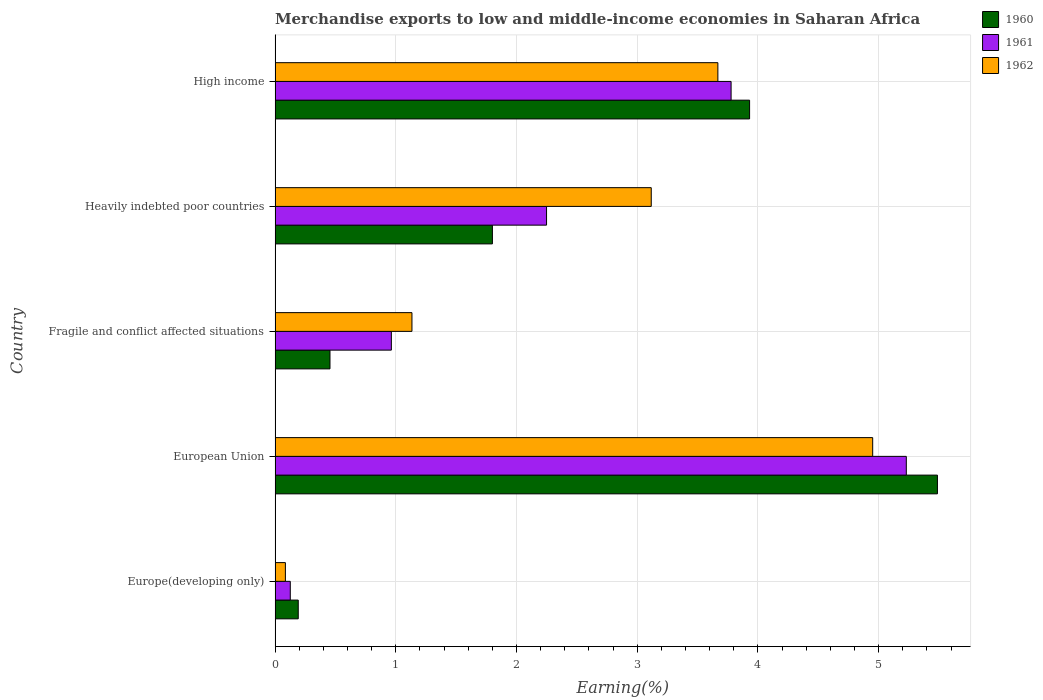How many different coloured bars are there?
Keep it short and to the point. 3. Are the number of bars per tick equal to the number of legend labels?
Your response must be concise. Yes. Are the number of bars on each tick of the Y-axis equal?
Provide a short and direct response. Yes. How many bars are there on the 1st tick from the top?
Offer a terse response. 3. What is the label of the 5th group of bars from the top?
Make the answer very short. Europe(developing only). What is the percentage of amount earned from merchandise exports in 1962 in High income?
Make the answer very short. 3.67. Across all countries, what is the maximum percentage of amount earned from merchandise exports in 1960?
Ensure brevity in your answer.  5.49. Across all countries, what is the minimum percentage of amount earned from merchandise exports in 1962?
Keep it short and to the point. 0.09. In which country was the percentage of amount earned from merchandise exports in 1961 minimum?
Offer a terse response. Europe(developing only). What is the total percentage of amount earned from merchandise exports in 1960 in the graph?
Your answer should be compact. 11.86. What is the difference between the percentage of amount earned from merchandise exports in 1962 in European Union and that in High income?
Offer a terse response. 1.28. What is the difference between the percentage of amount earned from merchandise exports in 1962 in Heavily indebted poor countries and the percentage of amount earned from merchandise exports in 1960 in Fragile and conflict affected situations?
Provide a short and direct response. 2.66. What is the average percentage of amount earned from merchandise exports in 1961 per country?
Ensure brevity in your answer.  2.47. What is the difference between the percentage of amount earned from merchandise exports in 1962 and percentage of amount earned from merchandise exports in 1960 in Europe(developing only)?
Provide a succinct answer. -0.11. What is the ratio of the percentage of amount earned from merchandise exports in 1961 in Europe(developing only) to that in High income?
Your answer should be very brief. 0.03. Is the difference between the percentage of amount earned from merchandise exports in 1962 in Heavily indebted poor countries and High income greater than the difference between the percentage of amount earned from merchandise exports in 1960 in Heavily indebted poor countries and High income?
Keep it short and to the point. Yes. What is the difference between the highest and the second highest percentage of amount earned from merchandise exports in 1960?
Keep it short and to the point. 1.56. What is the difference between the highest and the lowest percentage of amount earned from merchandise exports in 1962?
Offer a very short reply. 4.87. In how many countries, is the percentage of amount earned from merchandise exports in 1961 greater than the average percentage of amount earned from merchandise exports in 1961 taken over all countries?
Provide a short and direct response. 2. What does the 1st bar from the top in Heavily indebted poor countries represents?
Your answer should be very brief. 1962. What does the 2nd bar from the bottom in Fragile and conflict affected situations represents?
Your answer should be compact. 1961. How many bars are there?
Your response must be concise. 15. What is the difference between two consecutive major ticks on the X-axis?
Your answer should be compact. 1. Does the graph contain grids?
Provide a short and direct response. Yes. How many legend labels are there?
Keep it short and to the point. 3. How are the legend labels stacked?
Keep it short and to the point. Vertical. What is the title of the graph?
Give a very brief answer. Merchandise exports to low and middle-income economies in Saharan Africa. Does "1971" appear as one of the legend labels in the graph?
Offer a terse response. No. What is the label or title of the X-axis?
Provide a succinct answer. Earning(%). What is the Earning(%) in 1960 in Europe(developing only)?
Your answer should be very brief. 0.19. What is the Earning(%) in 1961 in Europe(developing only)?
Your answer should be compact. 0.13. What is the Earning(%) in 1962 in Europe(developing only)?
Your answer should be compact. 0.09. What is the Earning(%) in 1960 in European Union?
Your answer should be compact. 5.49. What is the Earning(%) of 1961 in European Union?
Give a very brief answer. 5.23. What is the Earning(%) of 1962 in European Union?
Keep it short and to the point. 4.95. What is the Earning(%) of 1960 in Fragile and conflict affected situations?
Offer a terse response. 0.45. What is the Earning(%) of 1961 in Fragile and conflict affected situations?
Your answer should be very brief. 0.96. What is the Earning(%) in 1962 in Fragile and conflict affected situations?
Your answer should be very brief. 1.13. What is the Earning(%) in 1960 in Heavily indebted poor countries?
Ensure brevity in your answer.  1.8. What is the Earning(%) in 1961 in Heavily indebted poor countries?
Your answer should be compact. 2.25. What is the Earning(%) of 1962 in Heavily indebted poor countries?
Offer a very short reply. 3.12. What is the Earning(%) in 1960 in High income?
Ensure brevity in your answer.  3.93. What is the Earning(%) of 1961 in High income?
Your answer should be very brief. 3.78. What is the Earning(%) of 1962 in High income?
Your answer should be very brief. 3.67. Across all countries, what is the maximum Earning(%) of 1960?
Provide a succinct answer. 5.49. Across all countries, what is the maximum Earning(%) of 1961?
Your answer should be compact. 5.23. Across all countries, what is the maximum Earning(%) of 1962?
Your response must be concise. 4.95. Across all countries, what is the minimum Earning(%) of 1960?
Provide a succinct answer. 0.19. Across all countries, what is the minimum Earning(%) in 1961?
Your answer should be compact. 0.13. Across all countries, what is the minimum Earning(%) in 1962?
Your response must be concise. 0.09. What is the total Earning(%) in 1960 in the graph?
Provide a short and direct response. 11.86. What is the total Earning(%) of 1961 in the graph?
Offer a very short reply. 12.34. What is the total Earning(%) in 1962 in the graph?
Your response must be concise. 12.95. What is the difference between the Earning(%) of 1960 in Europe(developing only) and that in European Union?
Offer a terse response. -5.29. What is the difference between the Earning(%) of 1961 in Europe(developing only) and that in European Union?
Offer a very short reply. -5.1. What is the difference between the Earning(%) in 1962 in Europe(developing only) and that in European Union?
Your answer should be compact. -4.87. What is the difference between the Earning(%) of 1960 in Europe(developing only) and that in Fragile and conflict affected situations?
Keep it short and to the point. -0.26. What is the difference between the Earning(%) in 1961 in Europe(developing only) and that in Fragile and conflict affected situations?
Offer a terse response. -0.84. What is the difference between the Earning(%) of 1962 in Europe(developing only) and that in Fragile and conflict affected situations?
Your response must be concise. -1.05. What is the difference between the Earning(%) in 1960 in Europe(developing only) and that in Heavily indebted poor countries?
Offer a very short reply. -1.61. What is the difference between the Earning(%) in 1961 in Europe(developing only) and that in Heavily indebted poor countries?
Your answer should be very brief. -2.12. What is the difference between the Earning(%) of 1962 in Europe(developing only) and that in Heavily indebted poor countries?
Provide a succinct answer. -3.03. What is the difference between the Earning(%) of 1960 in Europe(developing only) and that in High income?
Provide a succinct answer. -3.74. What is the difference between the Earning(%) of 1961 in Europe(developing only) and that in High income?
Give a very brief answer. -3.65. What is the difference between the Earning(%) in 1962 in Europe(developing only) and that in High income?
Offer a very short reply. -3.58. What is the difference between the Earning(%) of 1960 in European Union and that in Fragile and conflict affected situations?
Provide a short and direct response. 5.03. What is the difference between the Earning(%) of 1961 in European Union and that in Fragile and conflict affected situations?
Your response must be concise. 4.27. What is the difference between the Earning(%) of 1962 in European Union and that in Fragile and conflict affected situations?
Keep it short and to the point. 3.82. What is the difference between the Earning(%) of 1960 in European Union and that in Heavily indebted poor countries?
Your answer should be compact. 3.69. What is the difference between the Earning(%) of 1961 in European Union and that in Heavily indebted poor countries?
Offer a very short reply. 2.98. What is the difference between the Earning(%) in 1962 in European Union and that in Heavily indebted poor countries?
Keep it short and to the point. 1.83. What is the difference between the Earning(%) of 1960 in European Union and that in High income?
Offer a terse response. 1.56. What is the difference between the Earning(%) of 1961 in European Union and that in High income?
Keep it short and to the point. 1.45. What is the difference between the Earning(%) in 1962 in European Union and that in High income?
Make the answer very short. 1.28. What is the difference between the Earning(%) of 1960 in Fragile and conflict affected situations and that in Heavily indebted poor countries?
Give a very brief answer. -1.35. What is the difference between the Earning(%) in 1961 in Fragile and conflict affected situations and that in Heavily indebted poor countries?
Keep it short and to the point. -1.29. What is the difference between the Earning(%) of 1962 in Fragile and conflict affected situations and that in Heavily indebted poor countries?
Give a very brief answer. -1.98. What is the difference between the Earning(%) in 1960 in Fragile and conflict affected situations and that in High income?
Your response must be concise. -3.48. What is the difference between the Earning(%) of 1961 in Fragile and conflict affected situations and that in High income?
Keep it short and to the point. -2.81. What is the difference between the Earning(%) in 1962 in Fragile and conflict affected situations and that in High income?
Your response must be concise. -2.53. What is the difference between the Earning(%) of 1960 in Heavily indebted poor countries and that in High income?
Your answer should be compact. -2.13. What is the difference between the Earning(%) in 1961 in Heavily indebted poor countries and that in High income?
Make the answer very short. -1.53. What is the difference between the Earning(%) in 1962 in Heavily indebted poor countries and that in High income?
Ensure brevity in your answer.  -0.55. What is the difference between the Earning(%) of 1960 in Europe(developing only) and the Earning(%) of 1961 in European Union?
Offer a very short reply. -5.04. What is the difference between the Earning(%) in 1960 in Europe(developing only) and the Earning(%) in 1962 in European Union?
Your response must be concise. -4.76. What is the difference between the Earning(%) of 1961 in Europe(developing only) and the Earning(%) of 1962 in European Union?
Your answer should be very brief. -4.82. What is the difference between the Earning(%) in 1960 in Europe(developing only) and the Earning(%) in 1961 in Fragile and conflict affected situations?
Ensure brevity in your answer.  -0.77. What is the difference between the Earning(%) in 1960 in Europe(developing only) and the Earning(%) in 1962 in Fragile and conflict affected situations?
Provide a short and direct response. -0.94. What is the difference between the Earning(%) of 1961 in Europe(developing only) and the Earning(%) of 1962 in Fragile and conflict affected situations?
Your answer should be compact. -1.01. What is the difference between the Earning(%) in 1960 in Europe(developing only) and the Earning(%) in 1961 in Heavily indebted poor countries?
Keep it short and to the point. -2.06. What is the difference between the Earning(%) in 1960 in Europe(developing only) and the Earning(%) in 1962 in Heavily indebted poor countries?
Make the answer very short. -2.92. What is the difference between the Earning(%) of 1961 in Europe(developing only) and the Earning(%) of 1962 in Heavily indebted poor countries?
Provide a short and direct response. -2.99. What is the difference between the Earning(%) in 1960 in Europe(developing only) and the Earning(%) in 1961 in High income?
Offer a very short reply. -3.59. What is the difference between the Earning(%) in 1960 in Europe(developing only) and the Earning(%) in 1962 in High income?
Provide a short and direct response. -3.48. What is the difference between the Earning(%) in 1961 in Europe(developing only) and the Earning(%) in 1962 in High income?
Your response must be concise. -3.54. What is the difference between the Earning(%) of 1960 in European Union and the Earning(%) of 1961 in Fragile and conflict affected situations?
Your answer should be compact. 4.52. What is the difference between the Earning(%) of 1960 in European Union and the Earning(%) of 1962 in Fragile and conflict affected situations?
Make the answer very short. 4.35. What is the difference between the Earning(%) of 1961 in European Union and the Earning(%) of 1962 in Fragile and conflict affected situations?
Keep it short and to the point. 4.1. What is the difference between the Earning(%) of 1960 in European Union and the Earning(%) of 1961 in Heavily indebted poor countries?
Provide a succinct answer. 3.24. What is the difference between the Earning(%) in 1960 in European Union and the Earning(%) in 1962 in Heavily indebted poor countries?
Give a very brief answer. 2.37. What is the difference between the Earning(%) of 1961 in European Union and the Earning(%) of 1962 in Heavily indebted poor countries?
Provide a succinct answer. 2.11. What is the difference between the Earning(%) of 1960 in European Union and the Earning(%) of 1961 in High income?
Your answer should be compact. 1.71. What is the difference between the Earning(%) of 1960 in European Union and the Earning(%) of 1962 in High income?
Give a very brief answer. 1.82. What is the difference between the Earning(%) of 1961 in European Union and the Earning(%) of 1962 in High income?
Offer a very short reply. 1.56. What is the difference between the Earning(%) of 1960 in Fragile and conflict affected situations and the Earning(%) of 1961 in Heavily indebted poor countries?
Keep it short and to the point. -1.79. What is the difference between the Earning(%) of 1960 in Fragile and conflict affected situations and the Earning(%) of 1962 in Heavily indebted poor countries?
Provide a short and direct response. -2.66. What is the difference between the Earning(%) of 1961 in Fragile and conflict affected situations and the Earning(%) of 1962 in Heavily indebted poor countries?
Give a very brief answer. -2.15. What is the difference between the Earning(%) of 1960 in Fragile and conflict affected situations and the Earning(%) of 1961 in High income?
Your answer should be compact. -3.32. What is the difference between the Earning(%) in 1960 in Fragile and conflict affected situations and the Earning(%) in 1962 in High income?
Offer a terse response. -3.21. What is the difference between the Earning(%) of 1961 in Fragile and conflict affected situations and the Earning(%) of 1962 in High income?
Keep it short and to the point. -2.7. What is the difference between the Earning(%) in 1960 in Heavily indebted poor countries and the Earning(%) in 1961 in High income?
Ensure brevity in your answer.  -1.98. What is the difference between the Earning(%) in 1960 in Heavily indebted poor countries and the Earning(%) in 1962 in High income?
Ensure brevity in your answer.  -1.87. What is the difference between the Earning(%) of 1961 in Heavily indebted poor countries and the Earning(%) of 1962 in High income?
Give a very brief answer. -1.42. What is the average Earning(%) in 1960 per country?
Provide a short and direct response. 2.37. What is the average Earning(%) of 1961 per country?
Provide a succinct answer. 2.47. What is the average Earning(%) of 1962 per country?
Provide a succinct answer. 2.59. What is the difference between the Earning(%) of 1960 and Earning(%) of 1961 in Europe(developing only)?
Your answer should be compact. 0.07. What is the difference between the Earning(%) in 1960 and Earning(%) in 1962 in Europe(developing only)?
Your response must be concise. 0.11. What is the difference between the Earning(%) in 1961 and Earning(%) in 1962 in Europe(developing only)?
Your response must be concise. 0.04. What is the difference between the Earning(%) in 1960 and Earning(%) in 1961 in European Union?
Offer a very short reply. 0.26. What is the difference between the Earning(%) in 1960 and Earning(%) in 1962 in European Union?
Offer a terse response. 0.54. What is the difference between the Earning(%) of 1961 and Earning(%) of 1962 in European Union?
Give a very brief answer. 0.28. What is the difference between the Earning(%) of 1960 and Earning(%) of 1961 in Fragile and conflict affected situations?
Your answer should be very brief. -0.51. What is the difference between the Earning(%) in 1960 and Earning(%) in 1962 in Fragile and conflict affected situations?
Your answer should be very brief. -0.68. What is the difference between the Earning(%) in 1961 and Earning(%) in 1962 in Fragile and conflict affected situations?
Offer a terse response. -0.17. What is the difference between the Earning(%) of 1960 and Earning(%) of 1961 in Heavily indebted poor countries?
Provide a short and direct response. -0.45. What is the difference between the Earning(%) of 1960 and Earning(%) of 1962 in Heavily indebted poor countries?
Your response must be concise. -1.32. What is the difference between the Earning(%) in 1961 and Earning(%) in 1962 in Heavily indebted poor countries?
Ensure brevity in your answer.  -0.87. What is the difference between the Earning(%) in 1960 and Earning(%) in 1961 in High income?
Your answer should be very brief. 0.15. What is the difference between the Earning(%) in 1960 and Earning(%) in 1962 in High income?
Your answer should be very brief. 0.26. What is the difference between the Earning(%) in 1961 and Earning(%) in 1962 in High income?
Give a very brief answer. 0.11. What is the ratio of the Earning(%) in 1960 in Europe(developing only) to that in European Union?
Provide a succinct answer. 0.04. What is the ratio of the Earning(%) of 1961 in Europe(developing only) to that in European Union?
Keep it short and to the point. 0.02. What is the ratio of the Earning(%) of 1962 in Europe(developing only) to that in European Union?
Offer a very short reply. 0.02. What is the ratio of the Earning(%) of 1960 in Europe(developing only) to that in Fragile and conflict affected situations?
Offer a terse response. 0.42. What is the ratio of the Earning(%) in 1961 in Europe(developing only) to that in Fragile and conflict affected situations?
Provide a succinct answer. 0.13. What is the ratio of the Earning(%) in 1962 in Europe(developing only) to that in Fragile and conflict affected situations?
Your answer should be compact. 0.08. What is the ratio of the Earning(%) of 1960 in Europe(developing only) to that in Heavily indebted poor countries?
Provide a succinct answer. 0.11. What is the ratio of the Earning(%) of 1961 in Europe(developing only) to that in Heavily indebted poor countries?
Offer a very short reply. 0.06. What is the ratio of the Earning(%) of 1962 in Europe(developing only) to that in Heavily indebted poor countries?
Offer a very short reply. 0.03. What is the ratio of the Earning(%) in 1960 in Europe(developing only) to that in High income?
Your response must be concise. 0.05. What is the ratio of the Earning(%) in 1962 in Europe(developing only) to that in High income?
Provide a short and direct response. 0.02. What is the ratio of the Earning(%) of 1960 in European Union to that in Fragile and conflict affected situations?
Offer a very short reply. 12.06. What is the ratio of the Earning(%) in 1961 in European Union to that in Fragile and conflict affected situations?
Offer a terse response. 5.43. What is the ratio of the Earning(%) in 1962 in European Union to that in Fragile and conflict affected situations?
Offer a very short reply. 4.37. What is the ratio of the Earning(%) in 1960 in European Union to that in Heavily indebted poor countries?
Your response must be concise. 3.05. What is the ratio of the Earning(%) in 1961 in European Union to that in Heavily indebted poor countries?
Your response must be concise. 2.33. What is the ratio of the Earning(%) of 1962 in European Union to that in Heavily indebted poor countries?
Keep it short and to the point. 1.59. What is the ratio of the Earning(%) of 1960 in European Union to that in High income?
Give a very brief answer. 1.4. What is the ratio of the Earning(%) in 1961 in European Union to that in High income?
Give a very brief answer. 1.38. What is the ratio of the Earning(%) of 1962 in European Union to that in High income?
Give a very brief answer. 1.35. What is the ratio of the Earning(%) in 1960 in Fragile and conflict affected situations to that in Heavily indebted poor countries?
Ensure brevity in your answer.  0.25. What is the ratio of the Earning(%) in 1961 in Fragile and conflict affected situations to that in Heavily indebted poor countries?
Provide a short and direct response. 0.43. What is the ratio of the Earning(%) of 1962 in Fragile and conflict affected situations to that in Heavily indebted poor countries?
Your answer should be compact. 0.36. What is the ratio of the Earning(%) of 1960 in Fragile and conflict affected situations to that in High income?
Your response must be concise. 0.12. What is the ratio of the Earning(%) of 1961 in Fragile and conflict affected situations to that in High income?
Offer a very short reply. 0.26. What is the ratio of the Earning(%) of 1962 in Fragile and conflict affected situations to that in High income?
Your answer should be compact. 0.31. What is the ratio of the Earning(%) of 1960 in Heavily indebted poor countries to that in High income?
Keep it short and to the point. 0.46. What is the ratio of the Earning(%) in 1961 in Heavily indebted poor countries to that in High income?
Keep it short and to the point. 0.6. What is the ratio of the Earning(%) in 1962 in Heavily indebted poor countries to that in High income?
Provide a succinct answer. 0.85. What is the difference between the highest and the second highest Earning(%) in 1960?
Keep it short and to the point. 1.56. What is the difference between the highest and the second highest Earning(%) of 1961?
Provide a succinct answer. 1.45. What is the difference between the highest and the second highest Earning(%) in 1962?
Provide a short and direct response. 1.28. What is the difference between the highest and the lowest Earning(%) in 1960?
Make the answer very short. 5.29. What is the difference between the highest and the lowest Earning(%) of 1961?
Your answer should be very brief. 5.1. What is the difference between the highest and the lowest Earning(%) of 1962?
Make the answer very short. 4.87. 